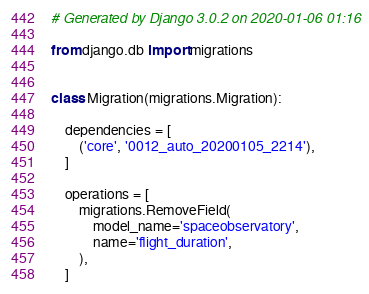<code> <loc_0><loc_0><loc_500><loc_500><_Python_># Generated by Django 3.0.2 on 2020-01-06 01:16

from django.db import migrations


class Migration(migrations.Migration):

    dependencies = [
        ('core', '0012_auto_20200105_2214'),
    ]

    operations = [
        migrations.RemoveField(
            model_name='spaceobservatory',
            name='flight_duration',
        ),
    ]
</code> 